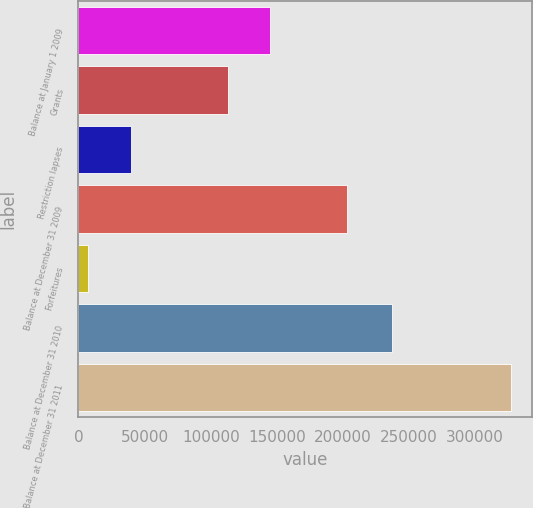Convert chart. <chart><loc_0><loc_0><loc_500><loc_500><bar_chart><fcel>Balance at January 1 2009<fcel>Grants<fcel>Restriction lapses<fcel>Balance at December 31 2009<fcel>Forfeitures<fcel>Balance at December 31 2010<fcel>Balance at December 31 2011<nl><fcel>145200<fcel>113250<fcel>39450<fcel>203250<fcel>7500<fcel>237150<fcel>327000<nl></chart> 